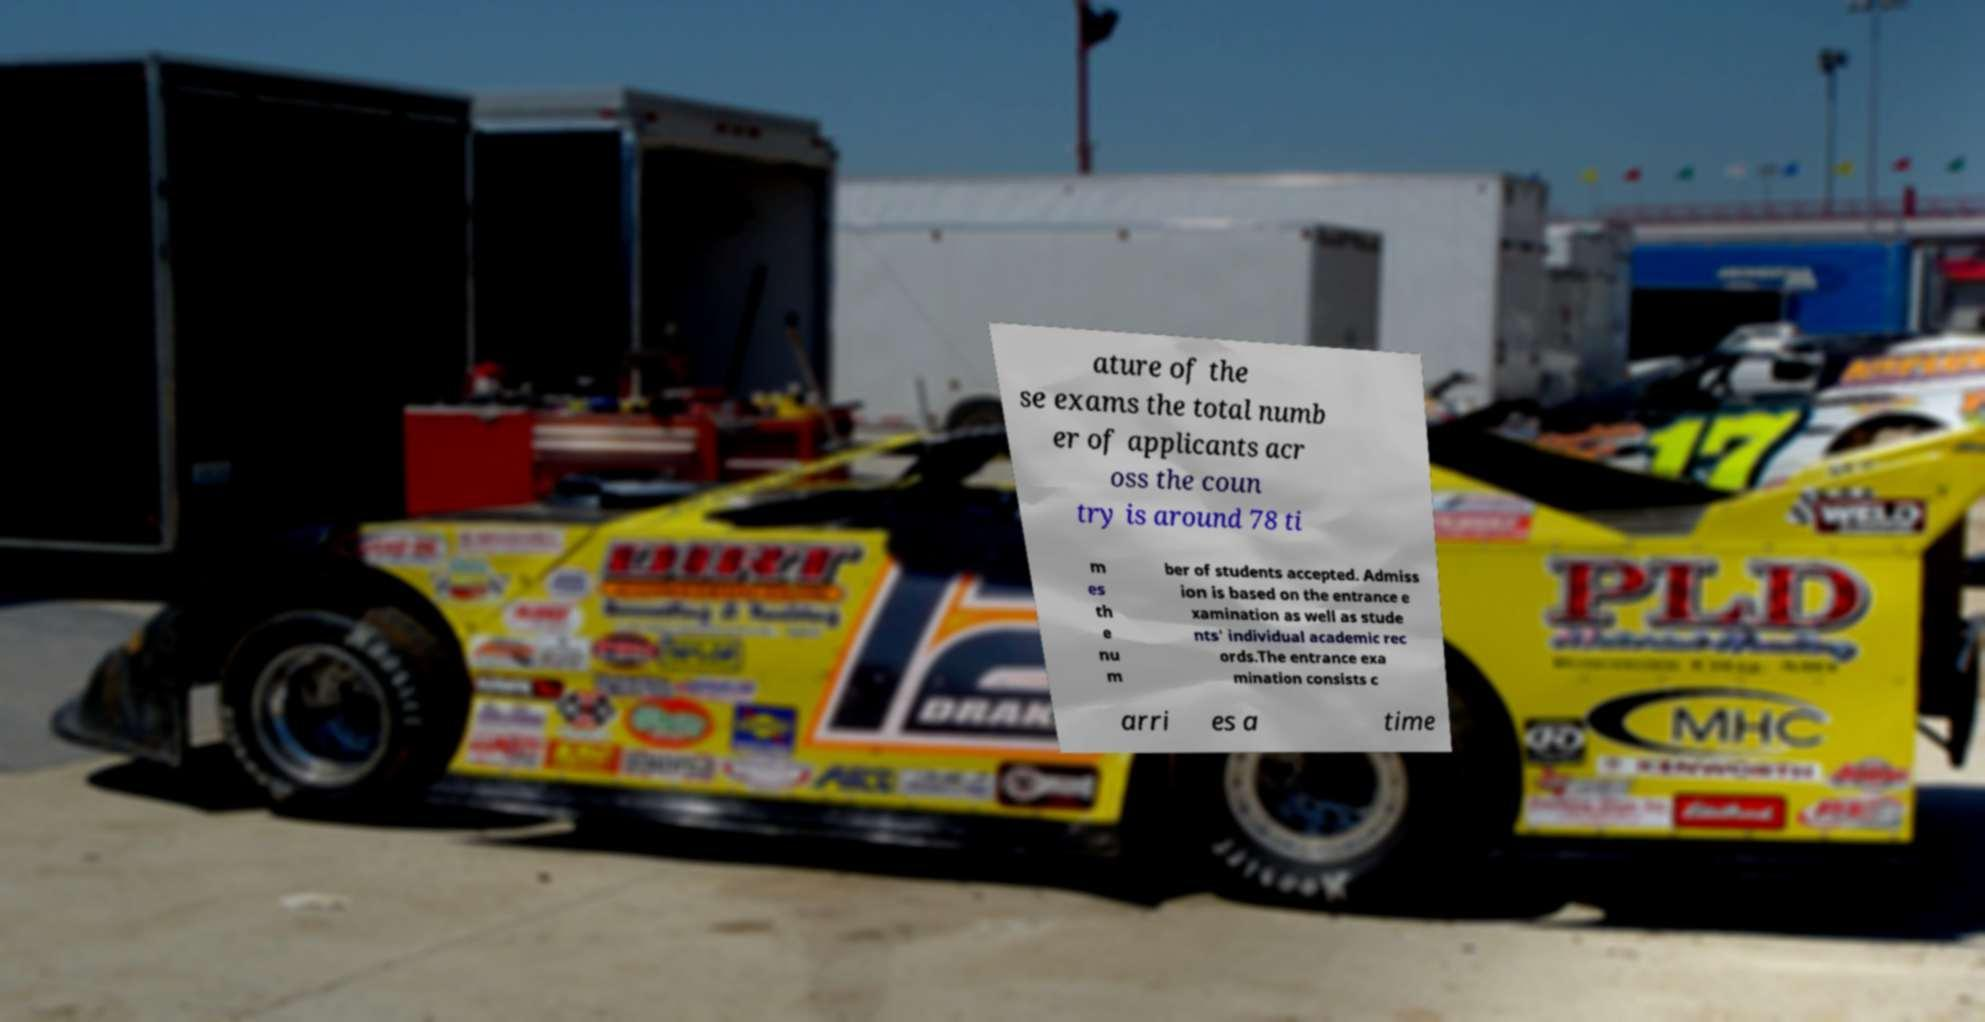Can you accurately transcribe the text from the provided image for me? ature of the se exams the total numb er of applicants acr oss the coun try is around 78 ti m es th e nu m ber of students accepted. Admiss ion is based on the entrance e xamination as well as stude nts' individual academic rec ords.The entrance exa mination consists c arri es a time 